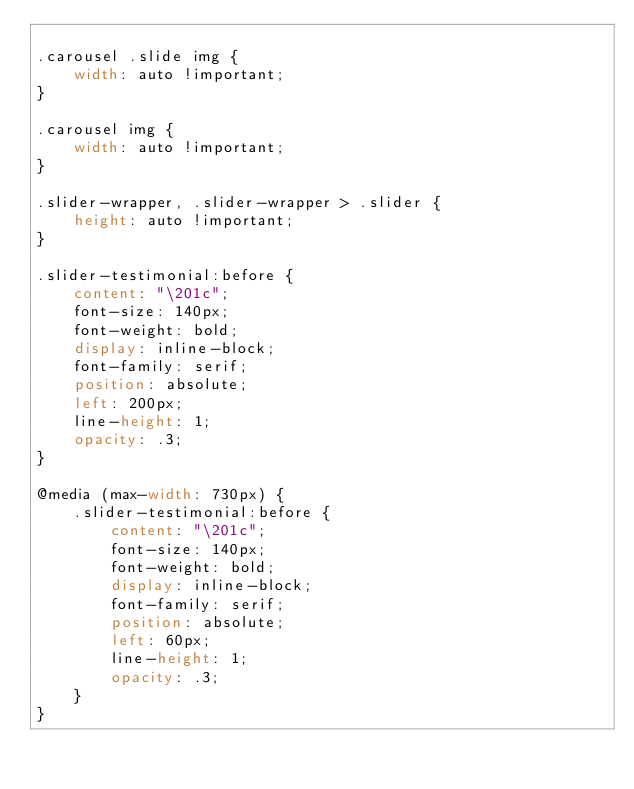Convert code to text. <code><loc_0><loc_0><loc_500><loc_500><_CSS_>
.carousel .slide img {
    width: auto !important;
}

.carousel img {
    width: auto !important;
}

.slider-wrapper, .slider-wrapper > .slider {
    height: auto !important;
}

.slider-testimonial:before {
    content: "\201c";
    font-size: 140px;
    font-weight: bold;
    display: inline-block;
    font-family: serif;
    position: absolute;
    left: 200px;
    line-height: 1;
    opacity: .3;
}

@media (max-width: 730px) { 
    .slider-testimonial:before {
        content: "\201c";
        font-size: 140px;
        font-weight: bold;
        display: inline-block;
        font-family: serif;
        position: absolute;
        left: 60px;
        line-height: 1;
        opacity: .3;
    } 
}</code> 